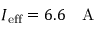Convert formula to latex. <formula><loc_0><loc_0><loc_500><loc_500>I _ { e f f } = 6 . 6 A</formula> 